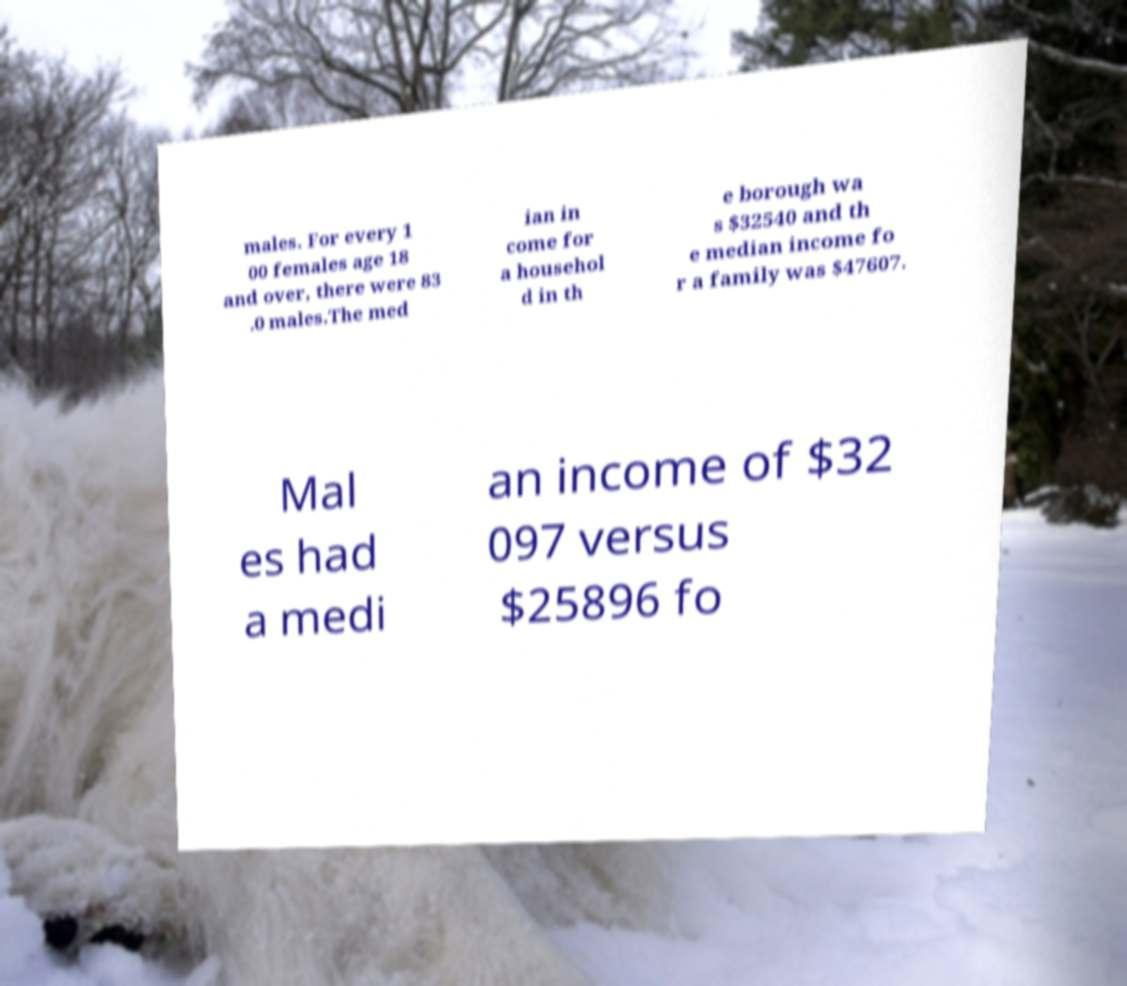Please identify and transcribe the text found in this image. males. For every 1 00 females age 18 and over, there were 83 .0 males.The med ian in come for a househol d in th e borough wa s $32540 and th e median income fo r a family was $47607. Mal es had a medi an income of $32 097 versus $25896 fo 